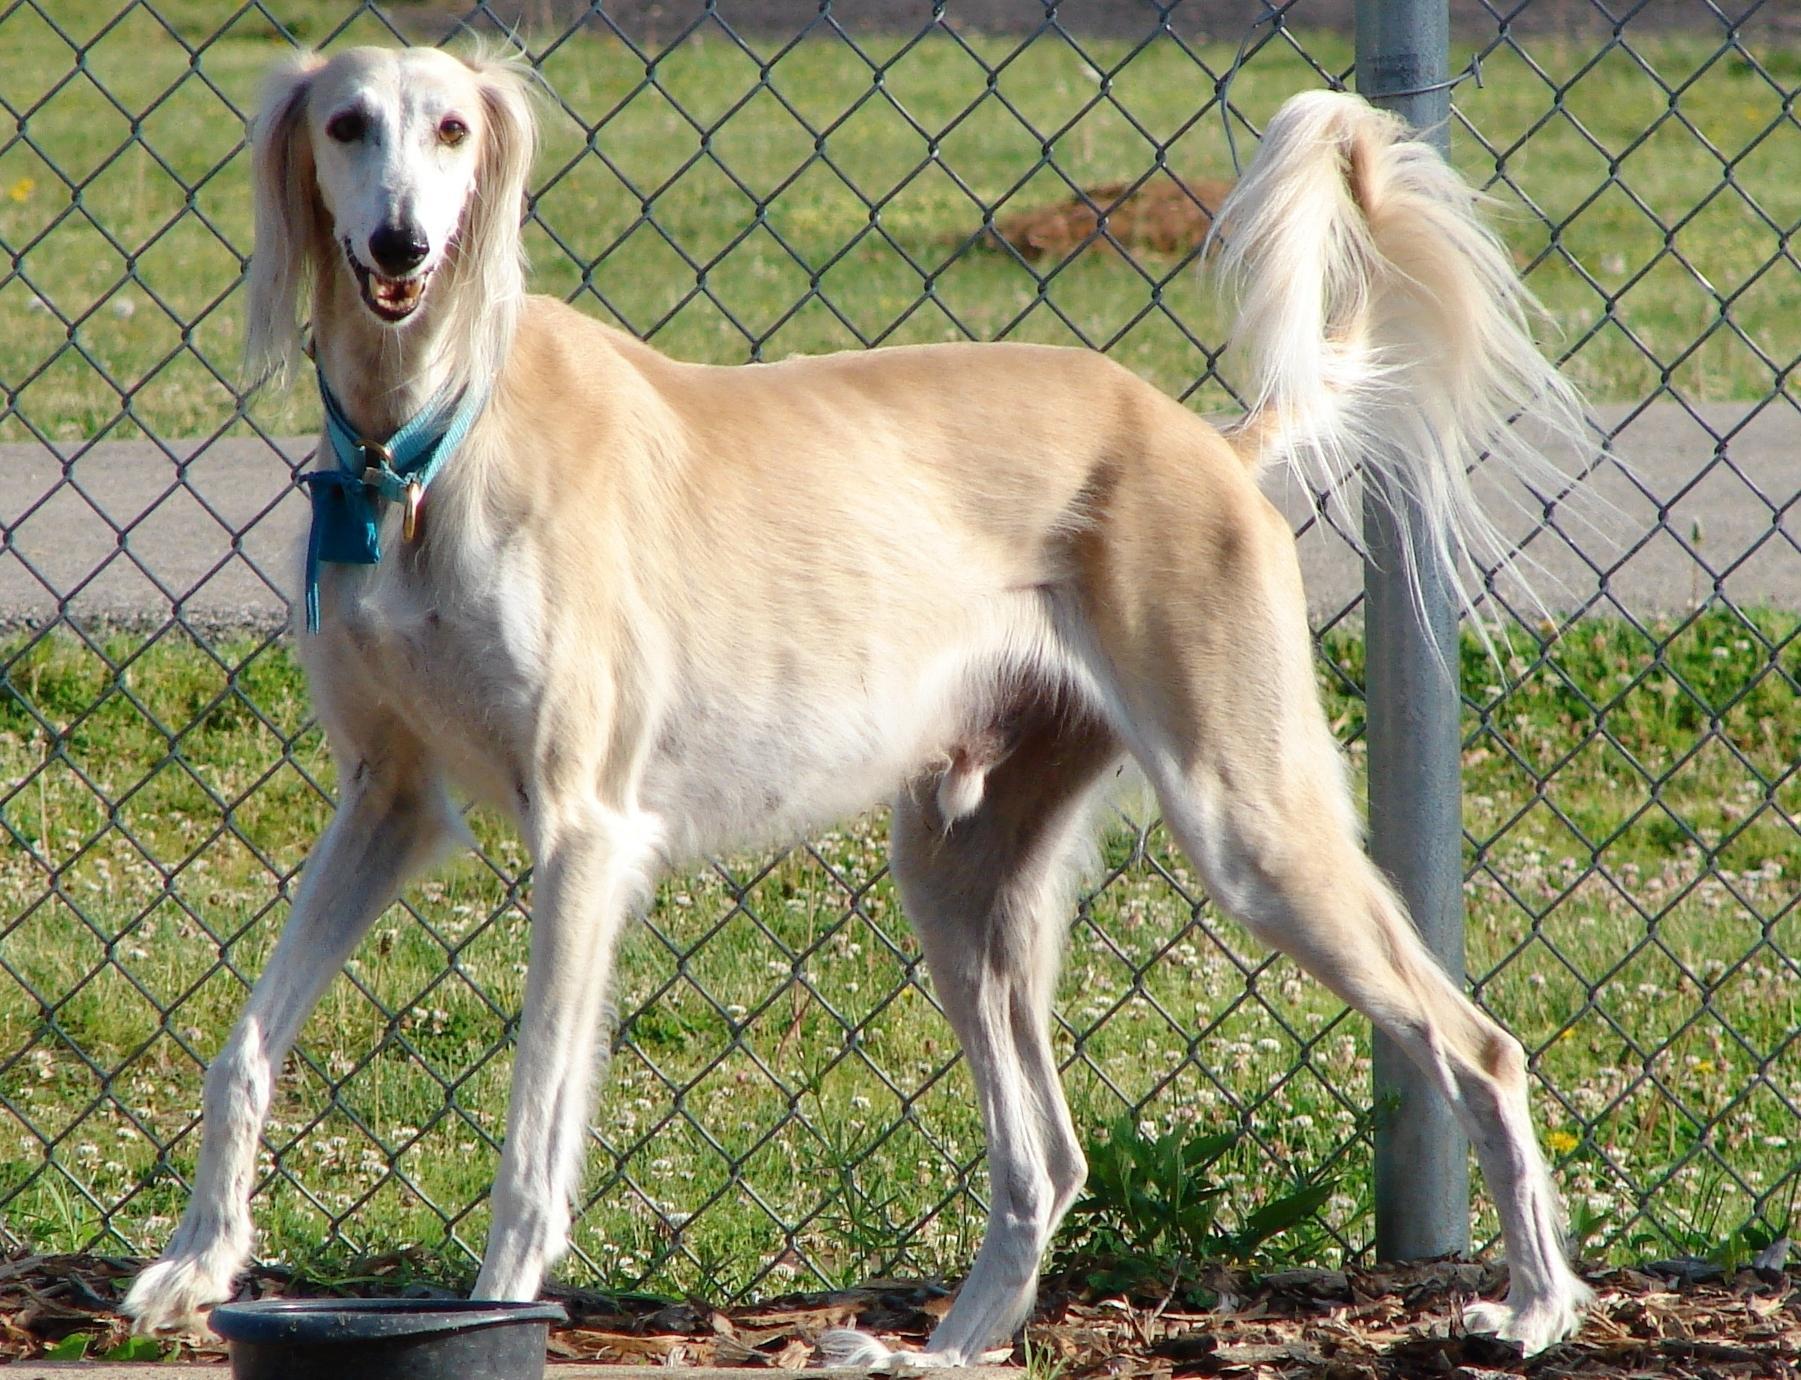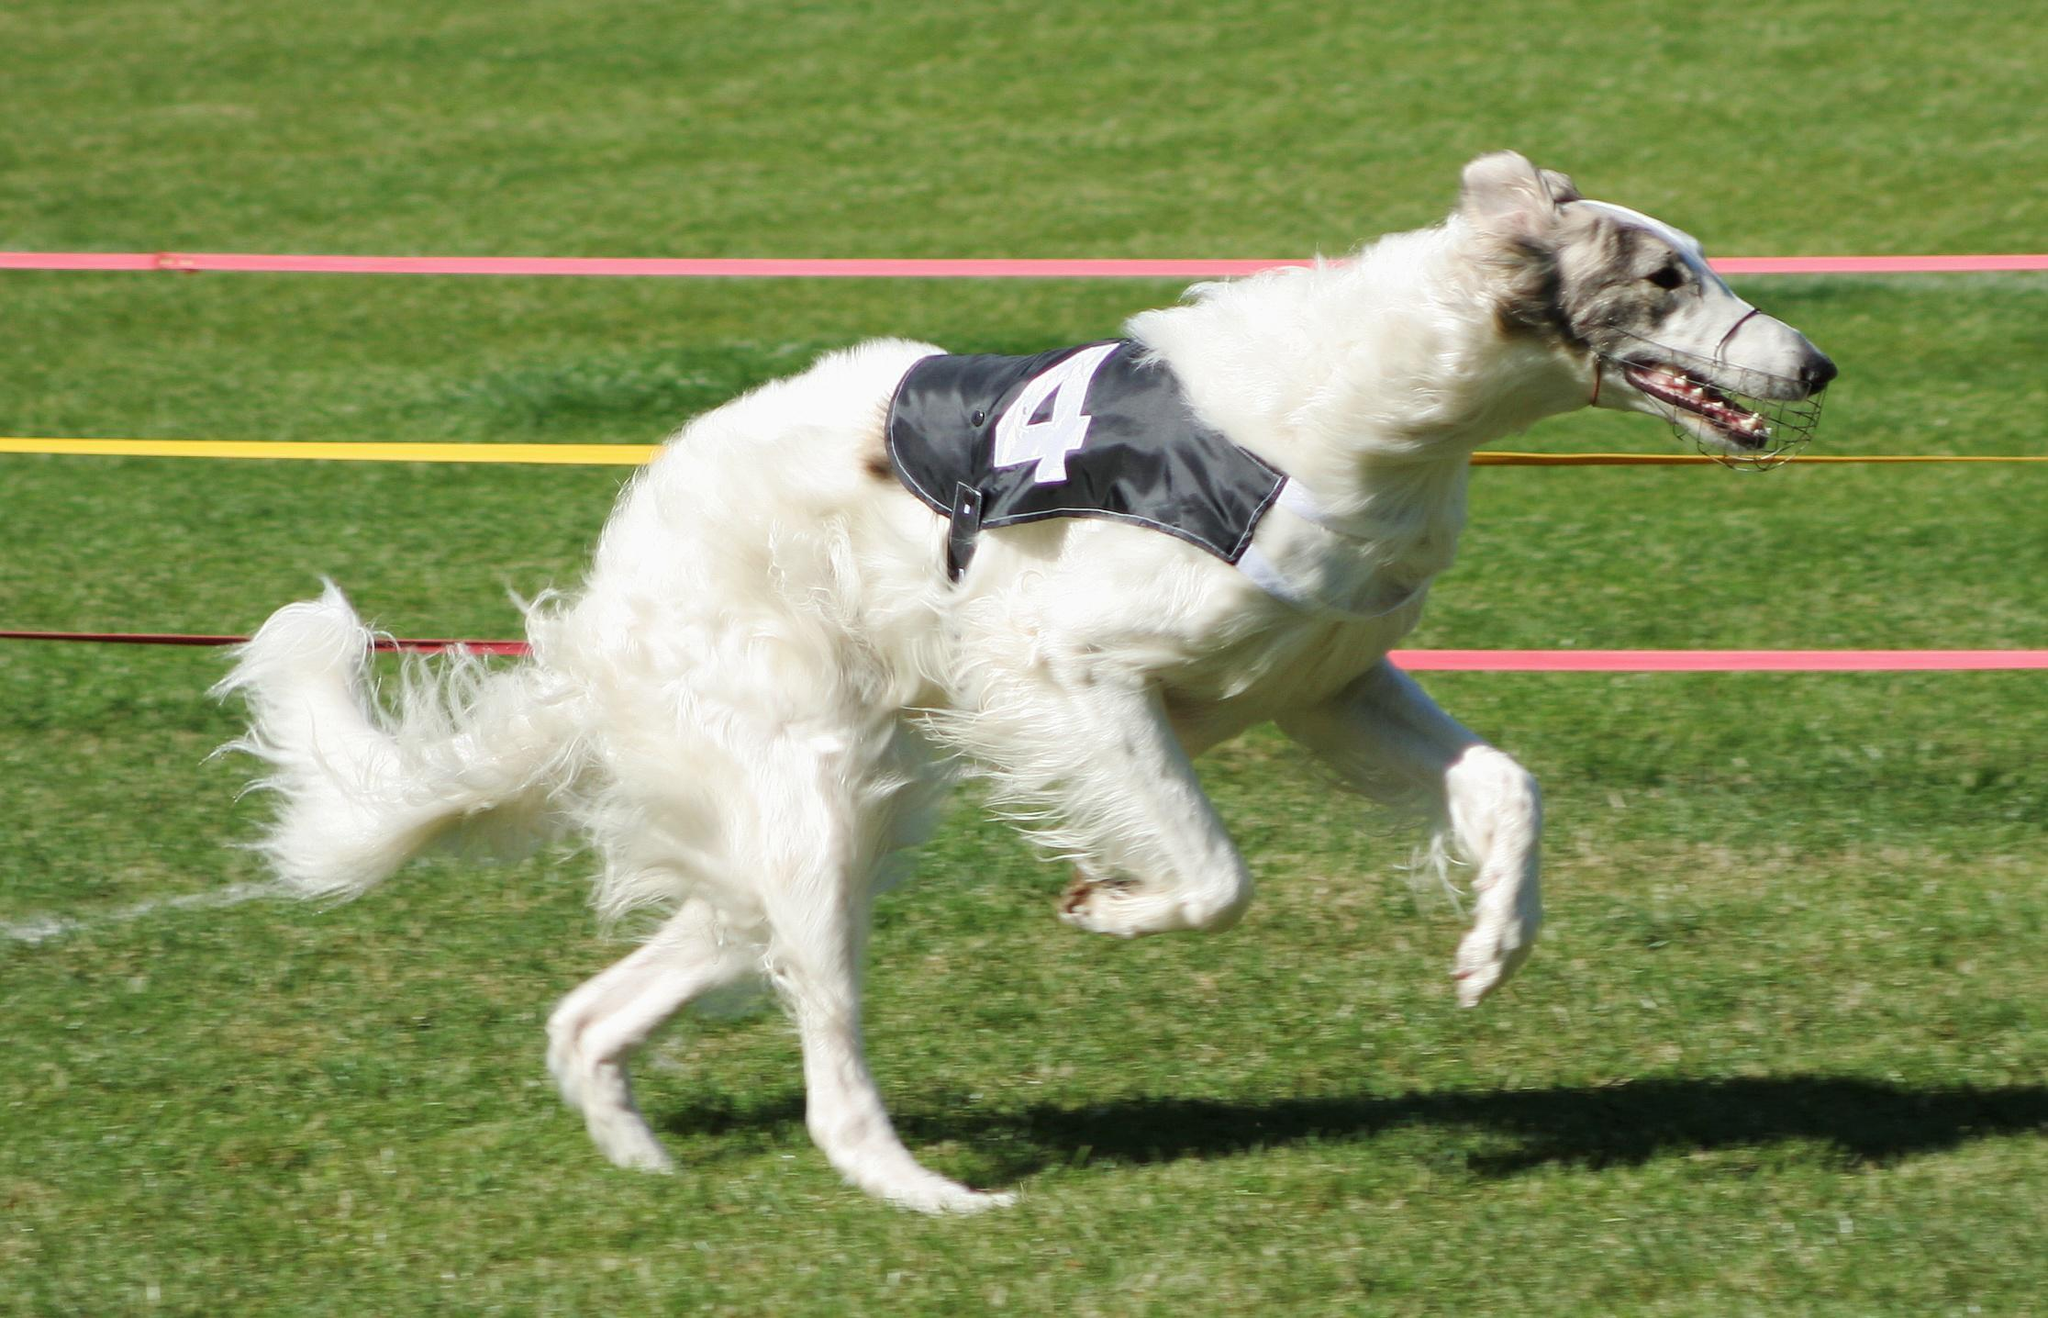The first image is the image on the left, the second image is the image on the right. Assess this claim about the two images: "An image shows a hound with at least its two front paws fully off the ground.". Correct or not? Answer yes or no. Yes. 